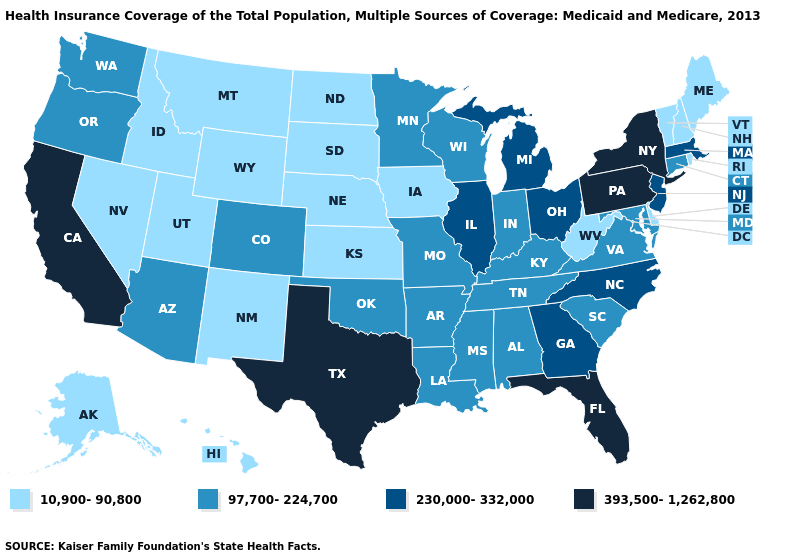Does New Mexico have the lowest value in the USA?
Short answer required. Yes. What is the value of Wisconsin?
Short answer required. 97,700-224,700. Which states hav the highest value in the South?
Short answer required. Florida, Texas. Name the states that have a value in the range 97,700-224,700?
Concise answer only. Alabama, Arizona, Arkansas, Colorado, Connecticut, Indiana, Kentucky, Louisiana, Maryland, Minnesota, Mississippi, Missouri, Oklahoma, Oregon, South Carolina, Tennessee, Virginia, Washington, Wisconsin. What is the highest value in the USA?
Quick response, please. 393,500-1,262,800. What is the value of Montana?
Answer briefly. 10,900-90,800. Name the states that have a value in the range 97,700-224,700?
Concise answer only. Alabama, Arizona, Arkansas, Colorado, Connecticut, Indiana, Kentucky, Louisiana, Maryland, Minnesota, Mississippi, Missouri, Oklahoma, Oregon, South Carolina, Tennessee, Virginia, Washington, Wisconsin. What is the value of Kentucky?
Answer briefly. 97,700-224,700. Which states have the lowest value in the USA?
Give a very brief answer. Alaska, Delaware, Hawaii, Idaho, Iowa, Kansas, Maine, Montana, Nebraska, Nevada, New Hampshire, New Mexico, North Dakota, Rhode Island, South Dakota, Utah, Vermont, West Virginia, Wyoming. Name the states that have a value in the range 97,700-224,700?
Answer briefly. Alabama, Arizona, Arkansas, Colorado, Connecticut, Indiana, Kentucky, Louisiana, Maryland, Minnesota, Mississippi, Missouri, Oklahoma, Oregon, South Carolina, Tennessee, Virginia, Washington, Wisconsin. Does the map have missing data?
Keep it brief. No. Which states have the highest value in the USA?
Keep it brief. California, Florida, New York, Pennsylvania, Texas. Among the states that border Wisconsin , which have the lowest value?
Concise answer only. Iowa. Name the states that have a value in the range 230,000-332,000?
Quick response, please. Georgia, Illinois, Massachusetts, Michigan, New Jersey, North Carolina, Ohio. 